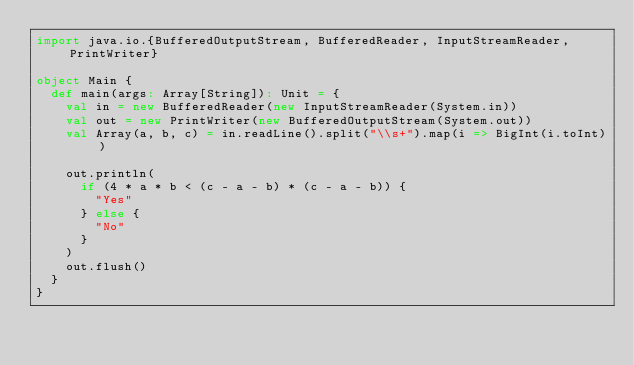<code> <loc_0><loc_0><loc_500><loc_500><_Scala_>import java.io.{BufferedOutputStream, BufferedReader, InputStreamReader, PrintWriter}

object Main {
  def main(args: Array[String]): Unit = {
    val in = new BufferedReader(new InputStreamReader(System.in))
    val out = new PrintWriter(new BufferedOutputStream(System.out))
    val Array(a, b, c) = in.readLine().split("\\s+").map(i => BigInt(i.toInt))

    out.println(
      if (4 * a * b < (c - a - b) * (c - a - b)) {
        "Yes"
      } else {
        "No"
      }
    )
    out.flush()
  }
}
</code> 